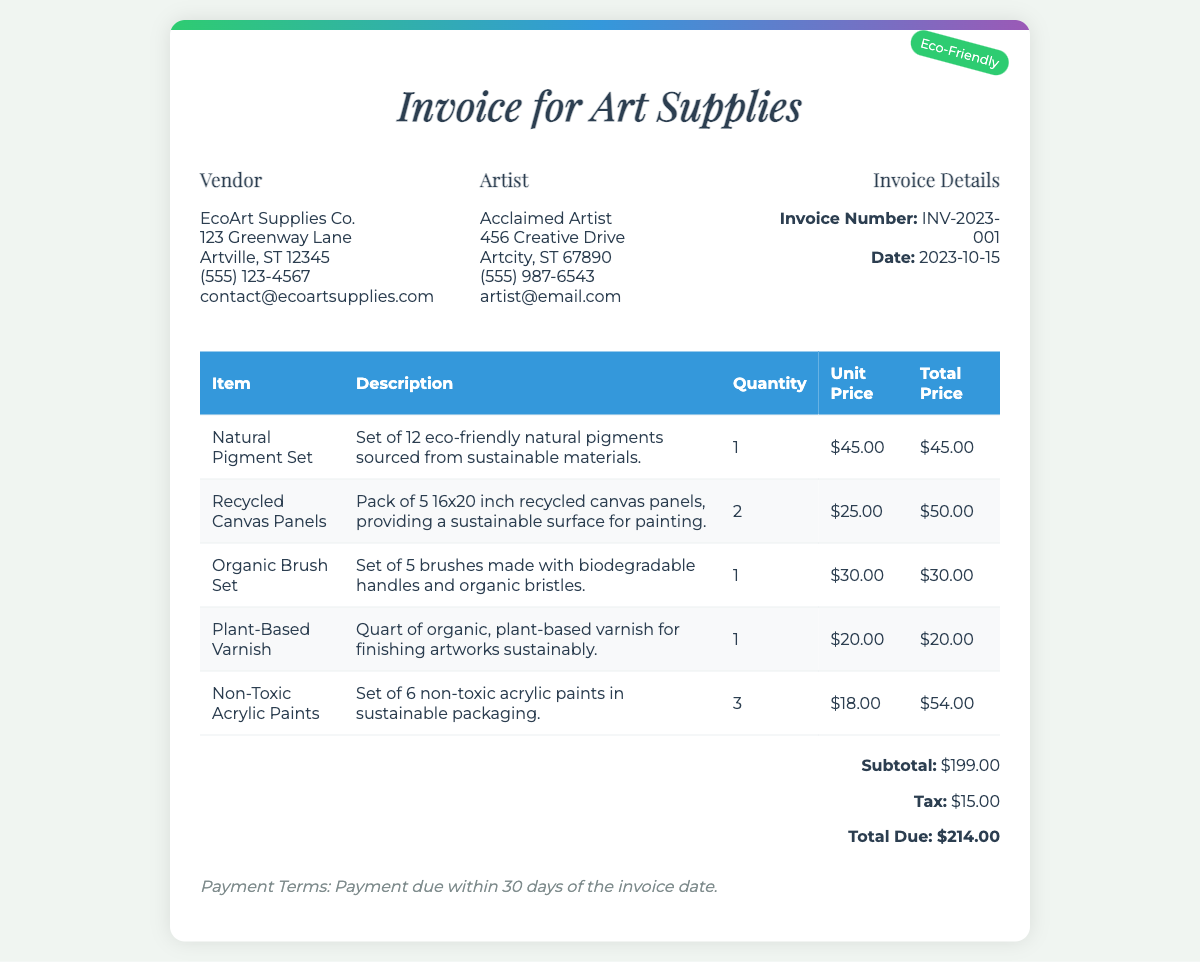what is the invoice number? The invoice number is a unique identifier for this transaction, which is mentioned in the document as INV-2023-001.
Answer: INV-2023-001 who is the vendor? The vendor providing the art supplies is named in the document, which is EcoArt Supplies Co.
Answer: EcoArt Supplies Co what is the total due amount? The total due amount is the sum of the subtotal and tax indicated in the invoice, which totals $214.00.
Answer: $214.00 how many organic brush sets were purchased? The number of organic brush sets purchased can be found in the materials list, which states a quantity of 1.
Answer: 1 what is the subtotal before taxes? The subtotal amount before any taxes are added is clearly stated in the document as $199.00.
Answer: $199.00 what is the date of the invoice? The date of the invoice is provided in the document, which is 2023-10-15.
Answer: 2023-10-15 what type of varnish was purchased? The document specifies that the varnish purchased is organic and plant-based, which highlights its sustainable characteristics.
Answer: plant-based how many sets of non-toxic acrylic paints were ordered? The number of sets of non-toxic acrylic paints ordered is mentioned in the itemized list as 3.
Answer: 3 what is the payment term stated in the invoice? The payment term mentioned outlines the due period for payment, which is within 30 days of the invoice date.
Answer: 30 days 